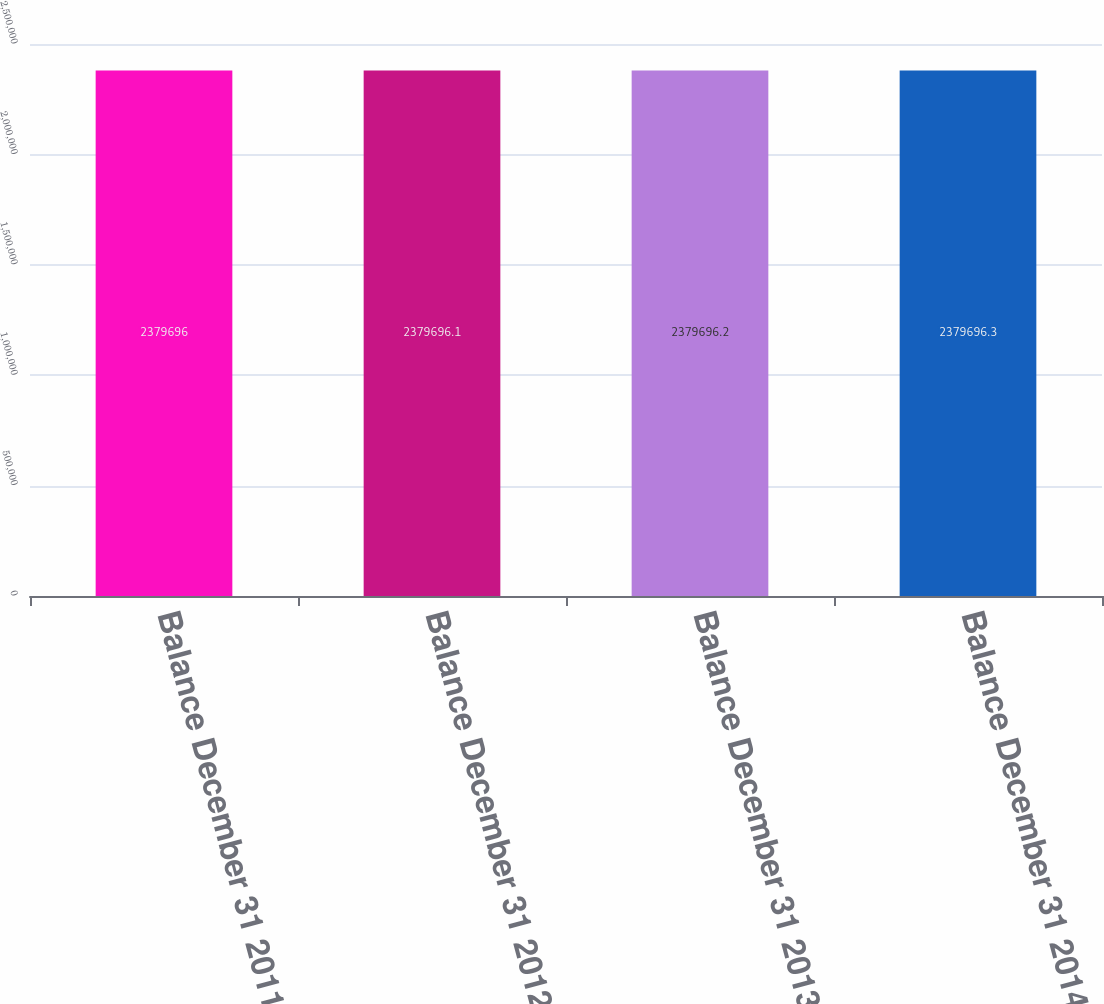Convert chart to OTSL. <chart><loc_0><loc_0><loc_500><loc_500><bar_chart><fcel>Balance December 31 2011<fcel>Balance December 31 2012<fcel>Balance December 31 2013<fcel>Balance December 31 2014<nl><fcel>2.3797e+06<fcel>2.3797e+06<fcel>2.3797e+06<fcel>2.3797e+06<nl></chart> 